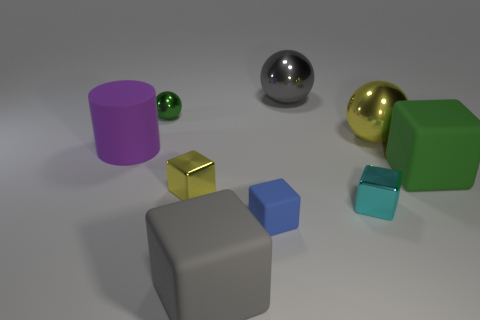Subtract all gray blocks. How many blocks are left? 4 Subtract all small yellow blocks. How many blocks are left? 4 Subtract all brown blocks. Subtract all purple cylinders. How many blocks are left? 5 Add 1 large objects. How many objects exist? 10 Subtract all cylinders. How many objects are left? 8 Subtract all big yellow metal cylinders. Subtract all large gray metal balls. How many objects are left? 8 Add 5 metal balls. How many metal balls are left? 8 Add 7 cyan metallic objects. How many cyan metallic objects exist? 8 Subtract 0 green cylinders. How many objects are left? 9 